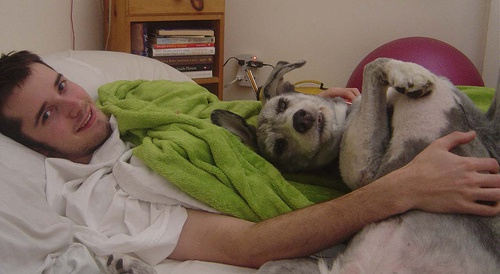Describe the objects in this image and their specific colors. I can see people in darkgray, olive, gray, and black tones, dog in darkgray, gray, and black tones, bed in darkgray and gray tones, sports ball in darkgray, brown, and purple tones, and book in darkgray and gray tones in this image. 